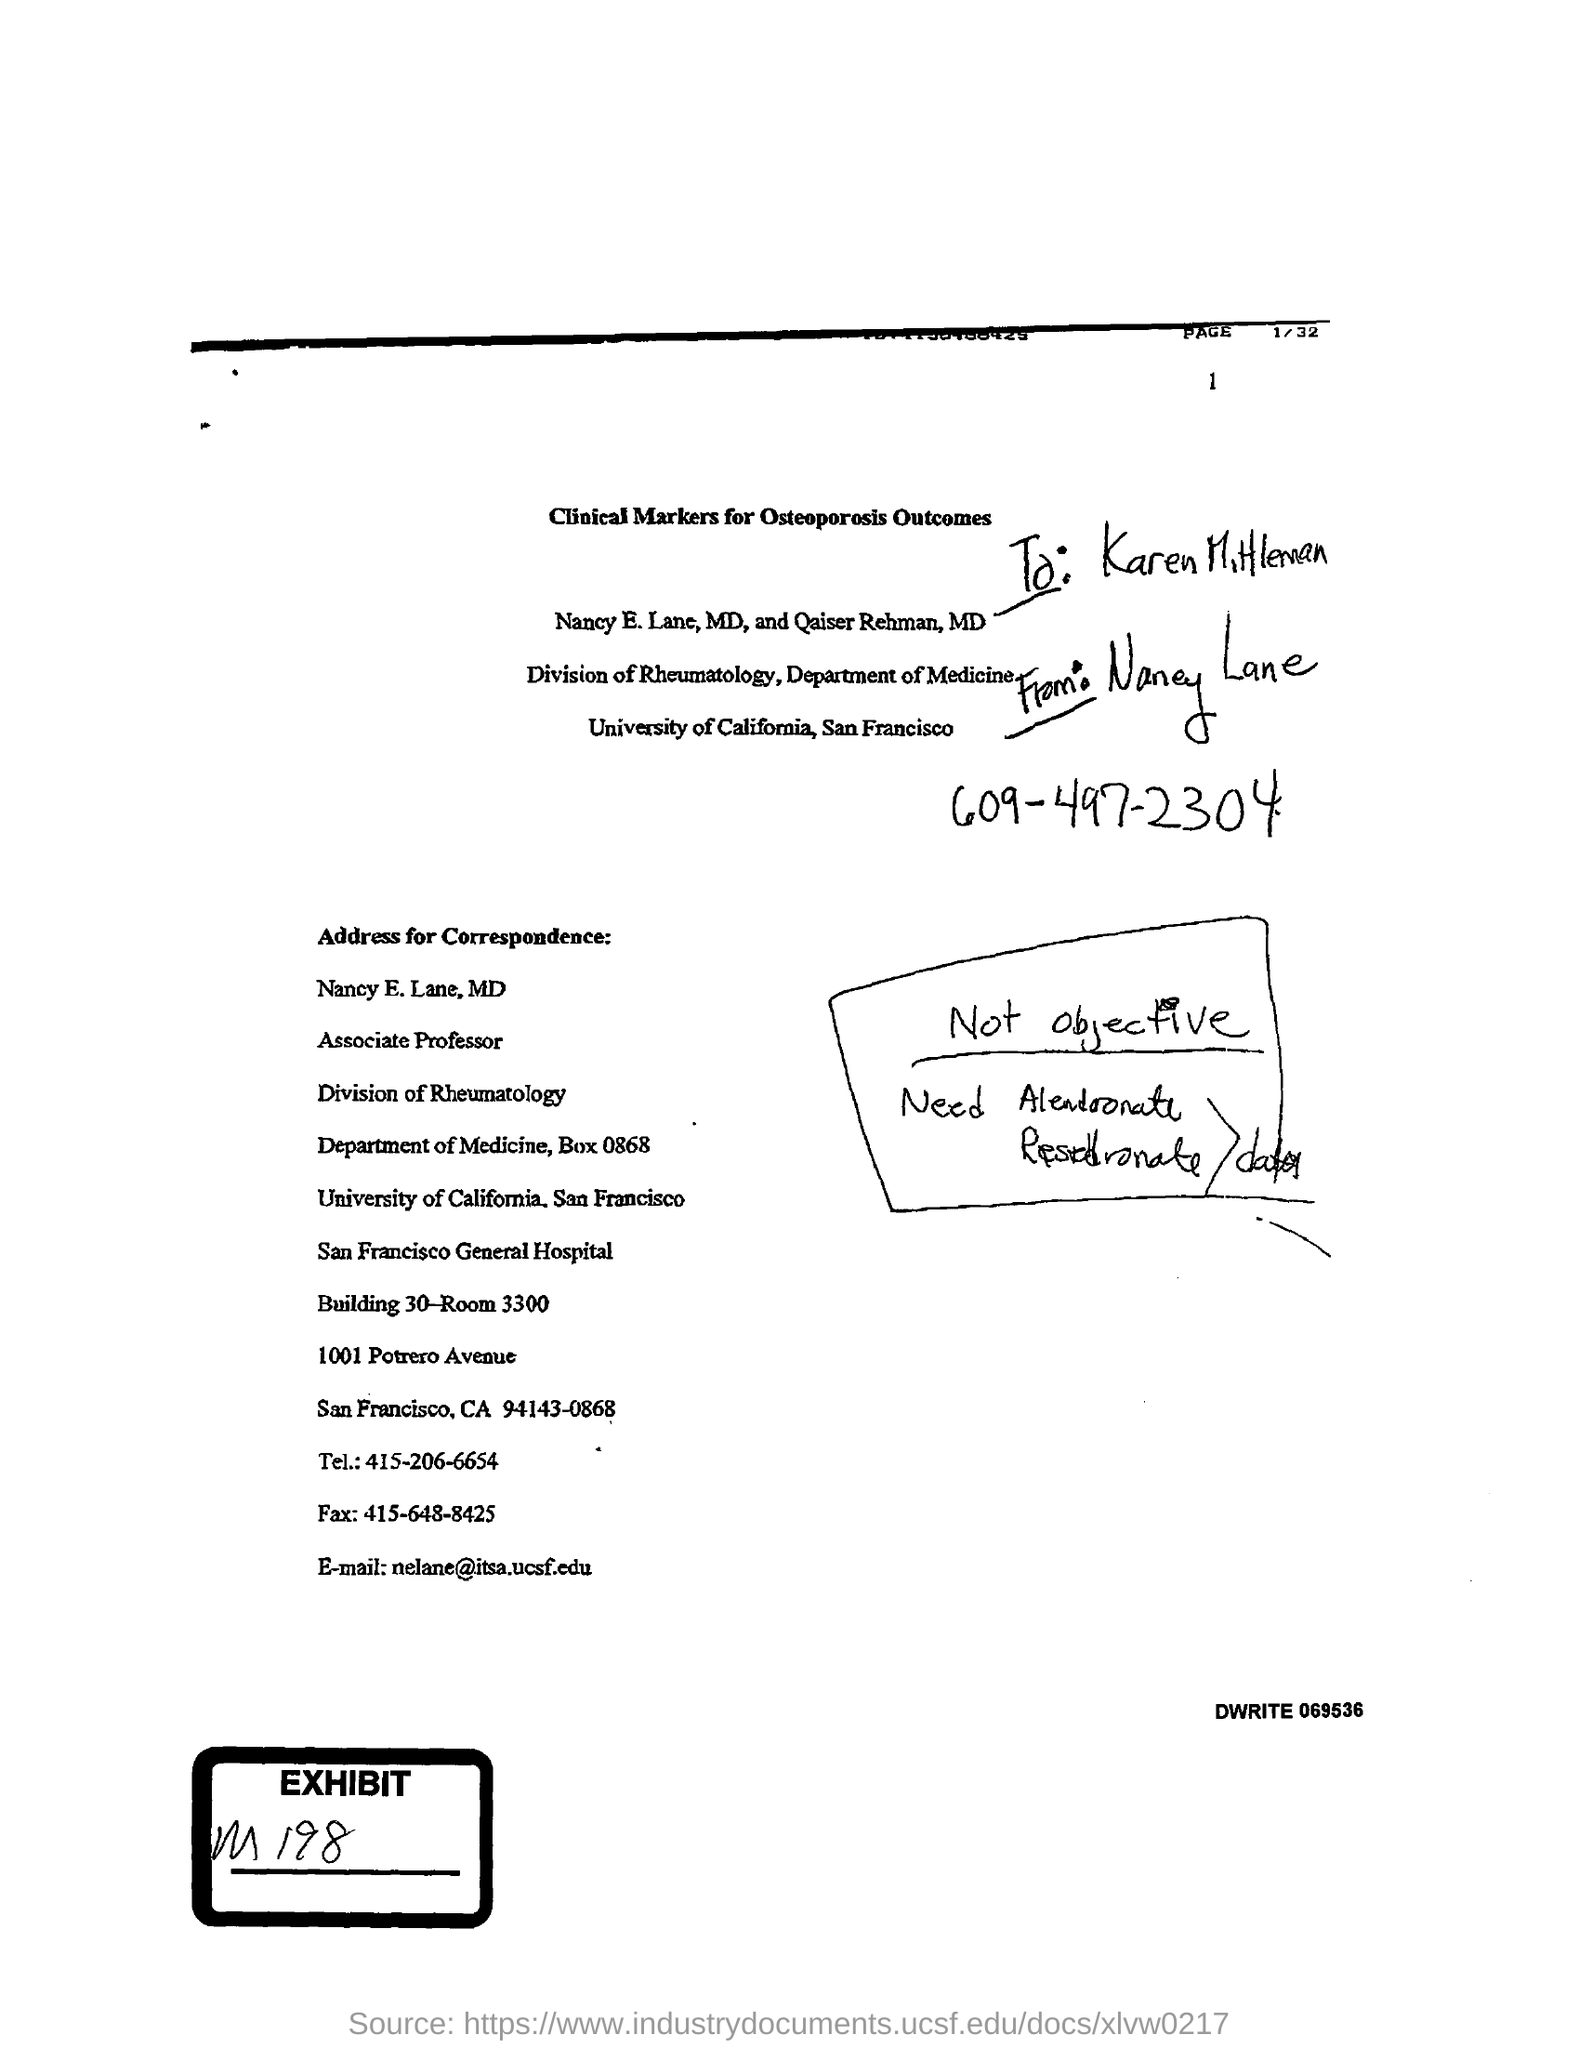To which department nancy e.lane belongs to ?
Your response must be concise. Department of medicine. To which division nancy e . lane belongs to ?
Keep it short and to the point. Division of Rheumatology. What is the fax number mentioned in the letter ?
Ensure brevity in your answer.  415-648-8425. What is the tel number mentioned in the given letter ?
Provide a succinct answer. 415-206-6654. 